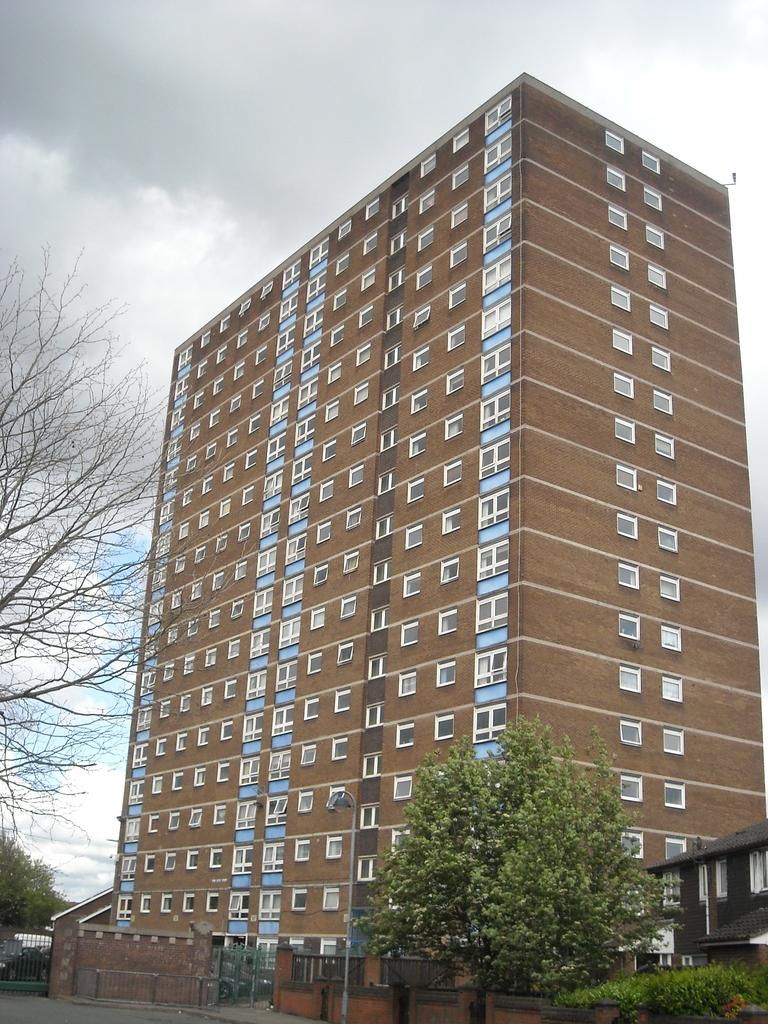What type of structures can be seen in the image? There is a building and a house in the image. What natural elements are present in the image? There are trees, plants, and a sky visible in the image. What architectural features can be observed in the image? There are gates, a fence, windows, and a wall in the image. What is visible in the background of the image? The sky is visible in the background of the image, with clouds present. What type of form can be seen on the night of the observation in the image? There is no specific form mentioned in the image, and the image does not indicate a particular time of day or observation. 